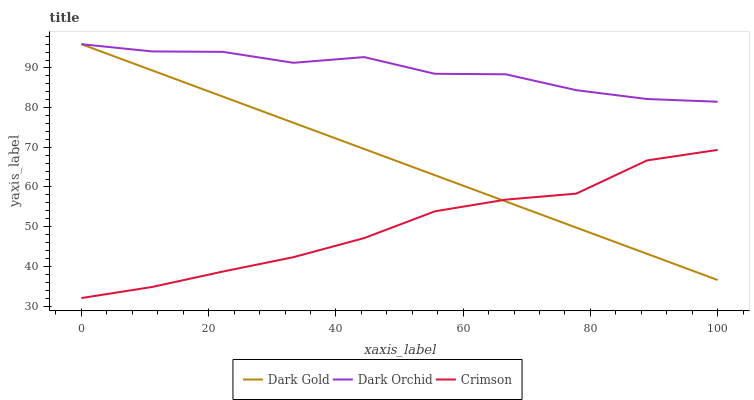Does Crimson have the minimum area under the curve?
Answer yes or no. Yes. Does Dark Orchid have the maximum area under the curve?
Answer yes or no. Yes. Does Dark Gold have the minimum area under the curve?
Answer yes or no. No. Does Dark Gold have the maximum area under the curve?
Answer yes or no. No. Is Dark Gold the smoothest?
Answer yes or no. Yes. Is Dark Orchid the roughest?
Answer yes or no. Yes. Is Dark Orchid the smoothest?
Answer yes or no. No. Is Dark Gold the roughest?
Answer yes or no. No. Does Crimson have the lowest value?
Answer yes or no. Yes. Does Dark Gold have the lowest value?
Answer yes or no. No. Does Dark Gold have the highest value?
Answer yes or no. Yes. Is Crimson less than Dark Orchid?
Answer yes or no. Yes. Is Dark Orchid greater than Crimson?
Answer yes or no. Yes. Does Dark Orchid intersect Dark Gold?
Answer yes or no. Yes. Is Dark Orchid less than Dark Gold?
Answer yes or no. No. Is Dark Orchid greater than Dark Gold?
Answer yes or no. No. Does Crimson intersect Dark Orchid?
Answer yes or no. No. 